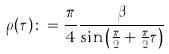<formula> <loc_0><loc_0><loc_500><loc_500>\rho ( \tau ) \colon = \frac { \pi } { 4 } \frac { \beta } { \sin \left ( \frac { \pi } { 2 } + \frac { \pi } { 2 } \tau \right ) }</formula> 